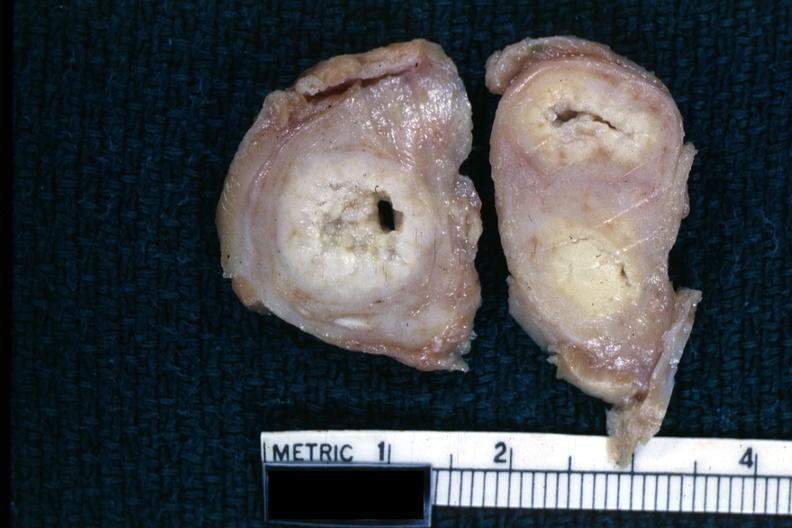s leiomyosarcoma present?
Answer the question using a single word or phrase. No 